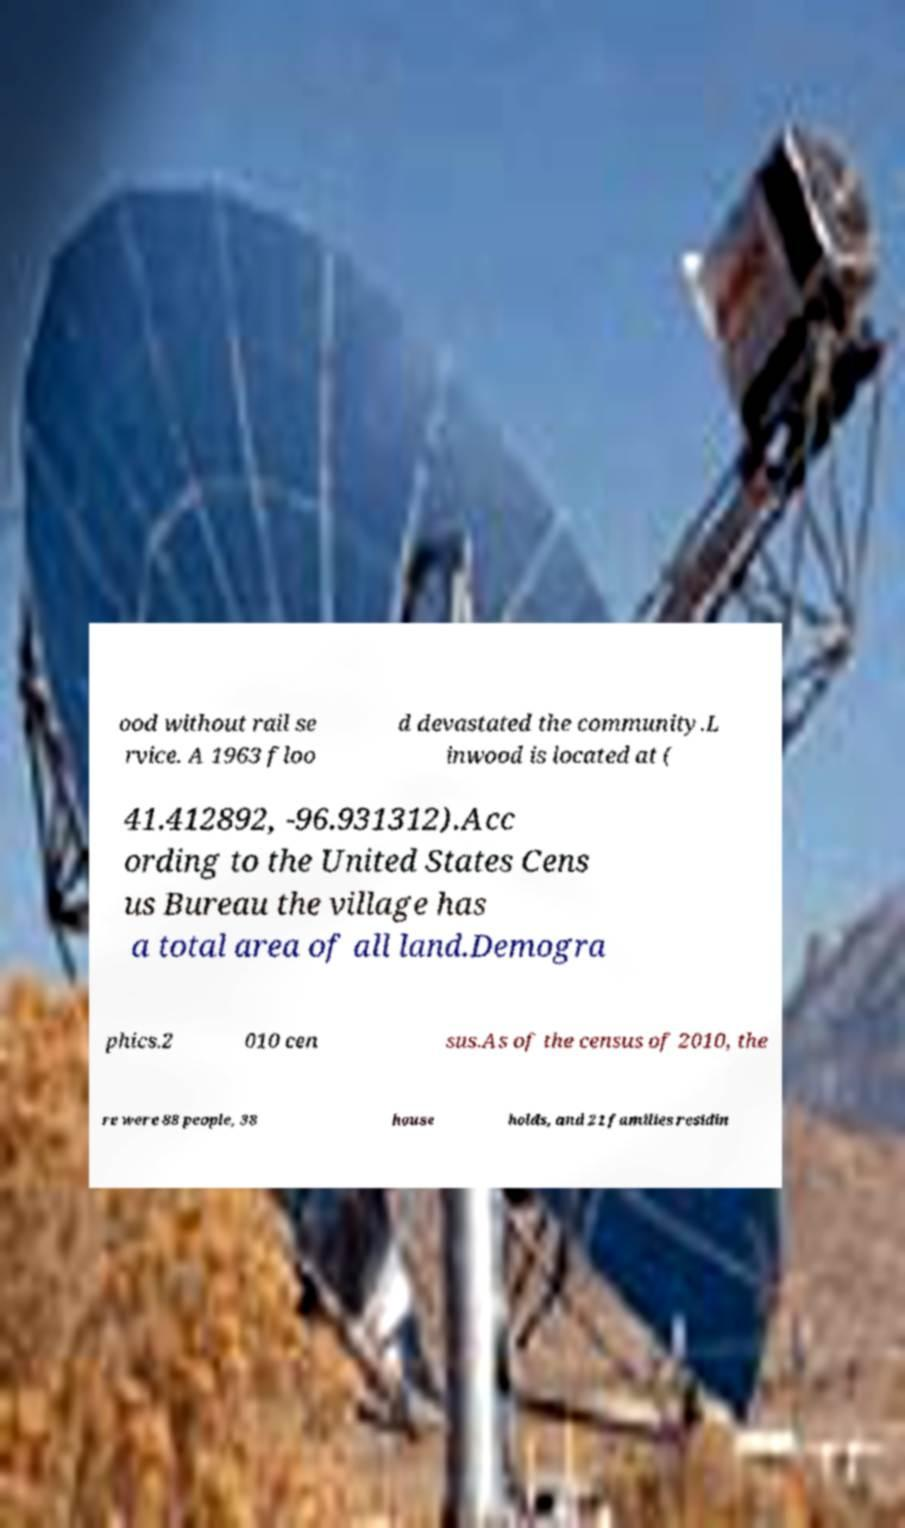Can you accurately transcribe the text from the provided image for me? ood without rail se rvice. A 1963 floo d devastated the community.L inwood is located at ( 41.412892, -96.931312).Acc ording to the United States Cens us Bureau the village has a total area of all land.Demogra phics.2 010 cen sus.As of the census of 2010, the re were 88 people, 38 house holds, and 21 families residin 